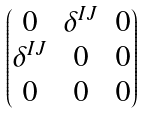Convert formula to latex. <formula><loc_0><loc_0><loc_500><loc_500>\begin{pmatrix} 0 & \delta ^ { I J } & 0 \\ \delta ^ { I J } & 0 & 0 \\ 0 & 0 & 0 \end{pmatrix}</formula> 